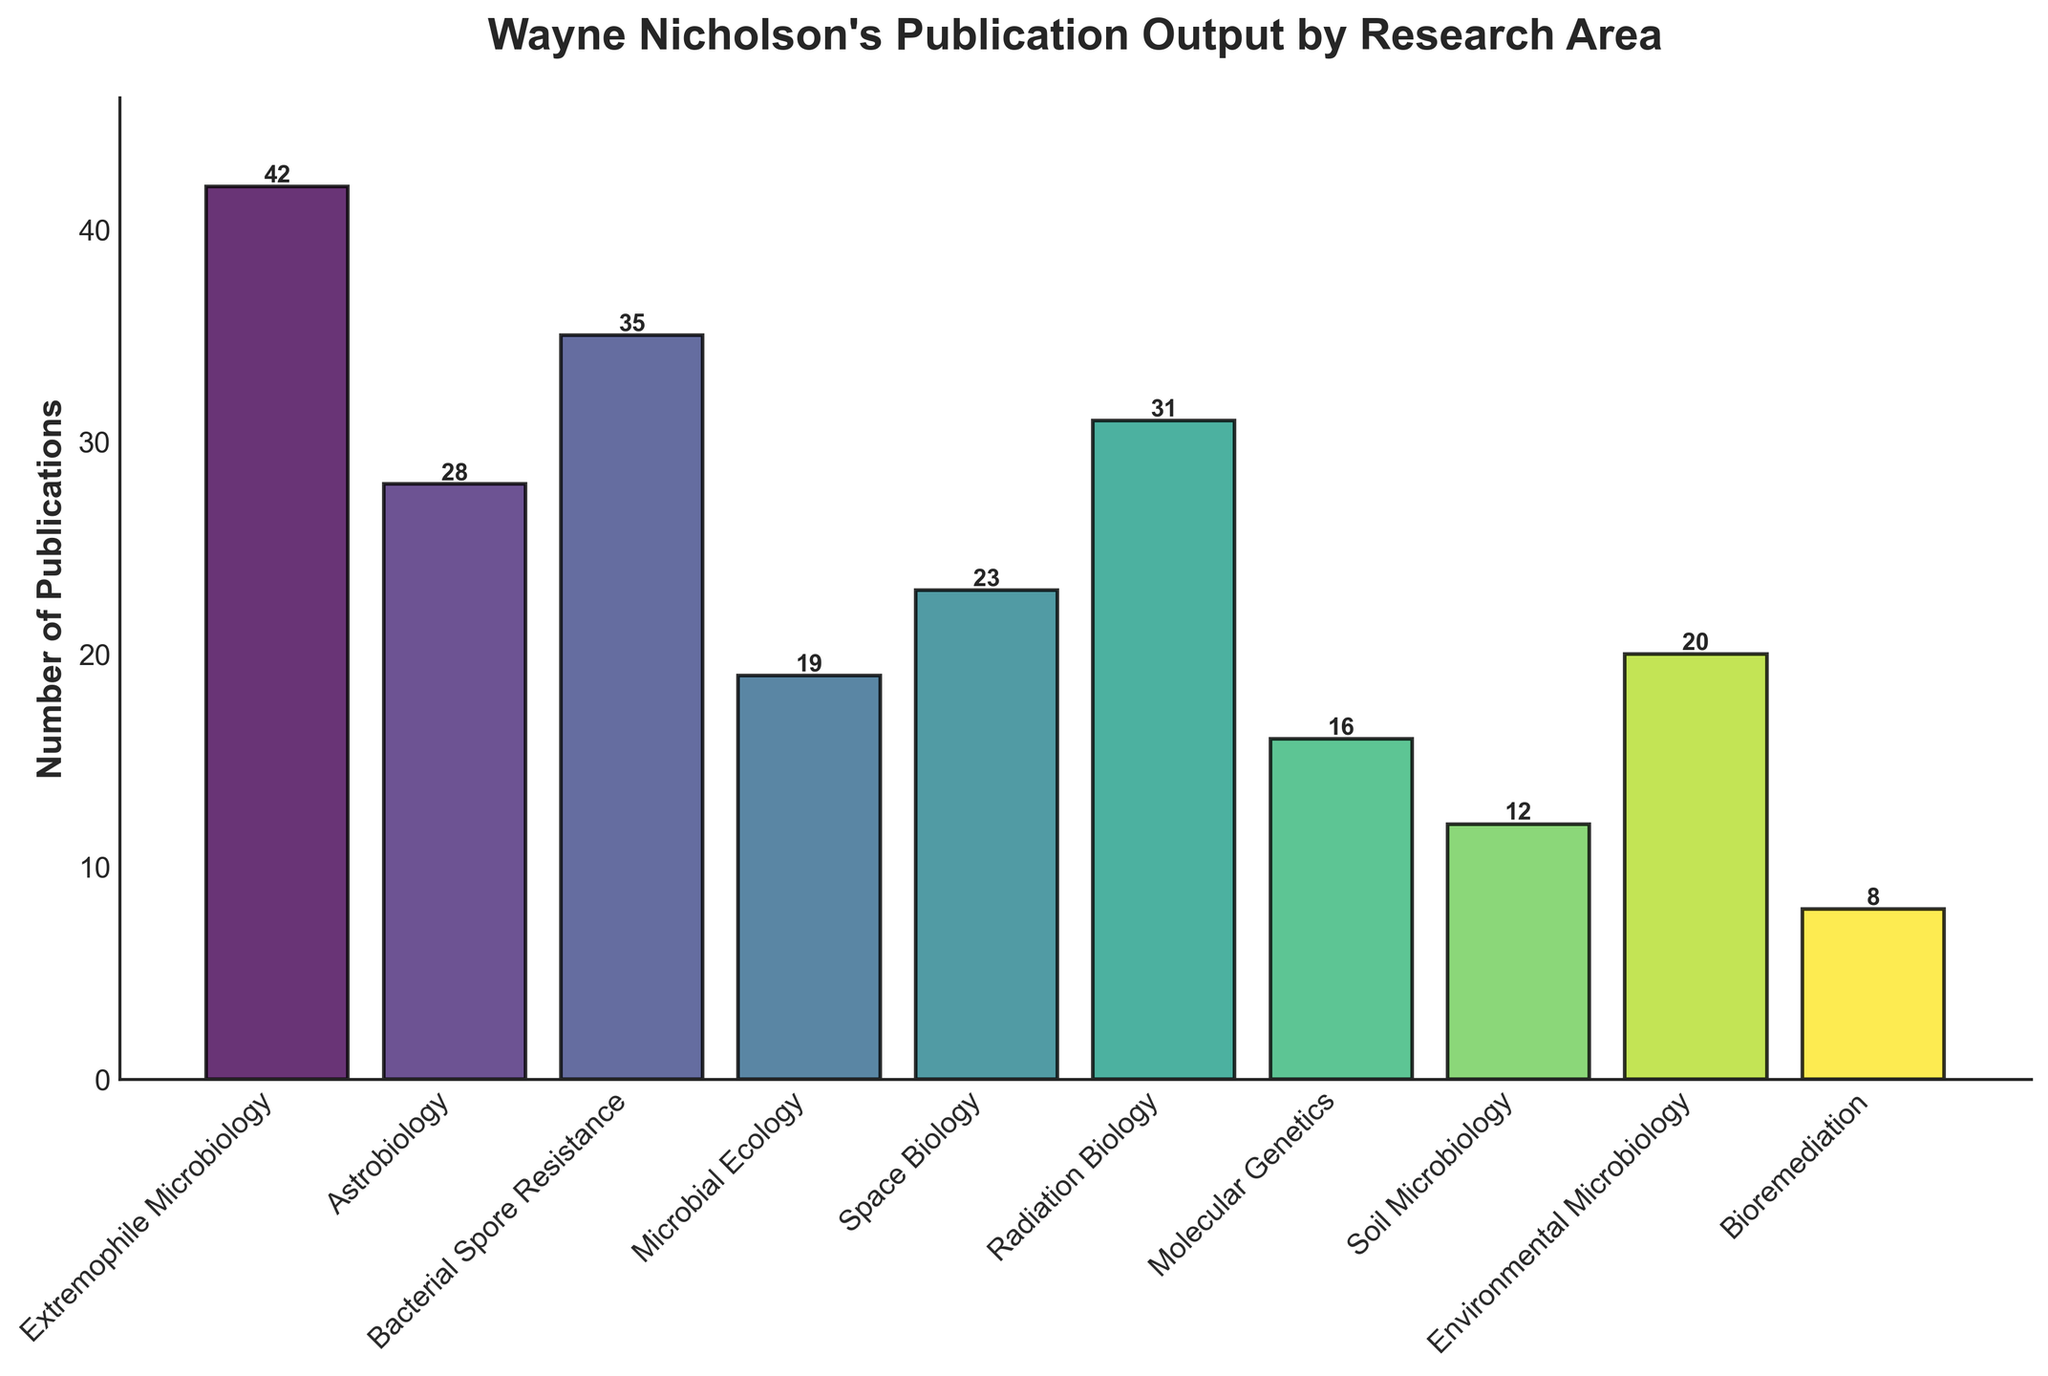Which research area has the highest number of publications? By examining the heights of the bars, Extremophile Microbiology has the tallest bar, indicating it has the highest number of publications.
Answer: Extremophile Microbiology What is the total number of publications in the areas of Astrobiology and Radiation Biology? Sum the publications from both areas: Astrobiology (28) + Radiation Biology (31) = 59
Answer: 59 How many more publications are there in Bacterial Spore Resistance compared to Bioremediation? Subtract the number of Bioremediation publications (8) from Bacterial Spore Resistance publications (35): 35 - 8 = 27
Answer: 27 Which areas have fewer publications than Microbial Ecology? Identify bars with heights shorter than Microbial Ecology (19): Soil Microbiology (12) and Bioremediation (8)
Answer: Soil Microbiology, Bioremediation What is the combined total of publications in Environmental Microbiology, Molecular Genetics, and Space Biology? Sum the publications in these areas: Environmental Microbiology (20) + Molecular Genetics (16) + Space Biology (23) = 59
Answer: 59 Which research area has the least number of publications? By examining the bar heights, Bioremediation has the shortest bar, indicating the least number of publications.
Answer: Bioremediation How many publications are there in total for Microbial Ecology and Soil Microbiology? Sum the publications of these areas: Microbial Ecology (19) + Soil Microbiology (12) = 31
Answer: 31 Is the number of publications in Molecular Genetics greater or less than Radiation Biology? Compare the two numbers: Molecular Genetics (16) is less than Radiation Biology (31)
Answer: Less What is the difference between the number of publications in Extremophile Microbiology and Environmental Microbiology? Subtract the publications in Environmental Microbiology (20) from Extremophile Microbiology (42): 42 - 20 = 22
Answer: 22 Which areas have publication numbers between 10 and 30 inclusive? Identify bars with heights within the range: Astrobiology (28), Bacterial Spore Resistance (35), Microbial Ecology (19), Space Biology (23), Radiation Biology (31), Molecular Genetics (16), Environmental Microbiology (20), Soil Microbiology (12)
Answer: Astrobiology, Microbial Ecology, Space Biology, Radiation Biology, Molecular Genetics, Environmental Microbiology, Soil Microbiology 